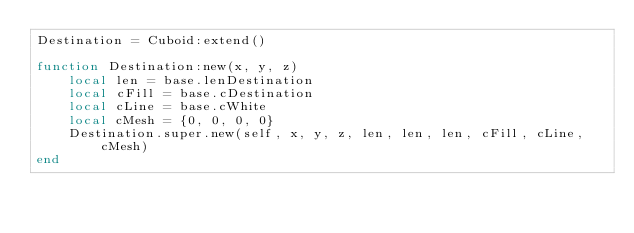<code> <loc_0><loc_0><loc_500><loc_500><_Lua_>Destination = Cuboid:extend()

function Destination:new(x, y, z)
    local len = base.lenDestination
    local cFill = base.cDestination
    local cLine = base.cWhite
    local cMesh = {0, 0, 0, 0}
    Destination.super.new(self, x, y, z, len, len, len, cFill, cLine, cMesh)
end</code> 